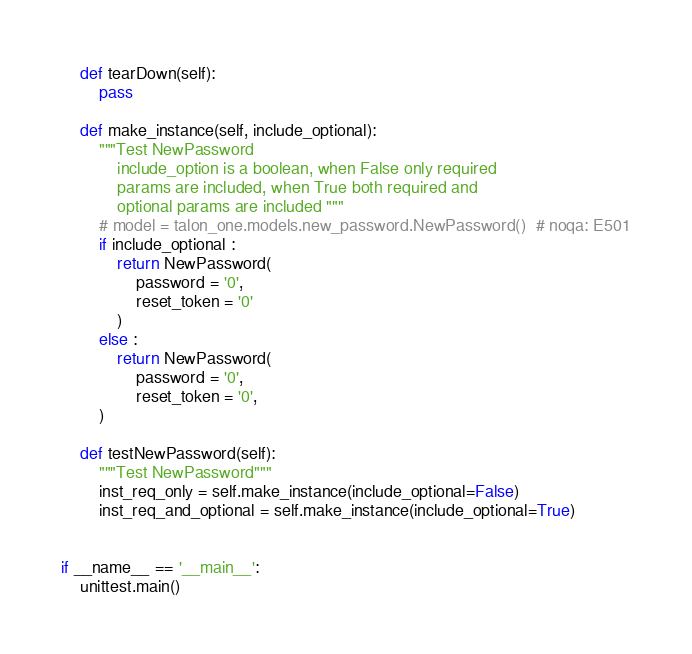<code> <loc_0><loc_0><loc_500><loc_500><_Python_>    def tearDown(self):
        pass

    def make_instance(self, include_optional):
        """Test NewPassword
            include_option is a boolean, when False only required
            params are included, when True both required and
            optional params are included """
        # model = talon_one.models.new_password.NewPassword()  # noqa: E501
        if include_optional :
            return NewPassword(
                password = '0', 
                reset_token = '0'
            )
        else :
            return NewPassword(
                password = '0',
                reset_token = '0',
        )

    def testNewPassword(self):
        """Test NewPassword"""
        inst_req_only = self.make_instance(include_optional=False)
        inst_req_and_optional = self.make_instance(include_optional=True)


if __name__ == '__main__':
    unittest.main()
</code> 